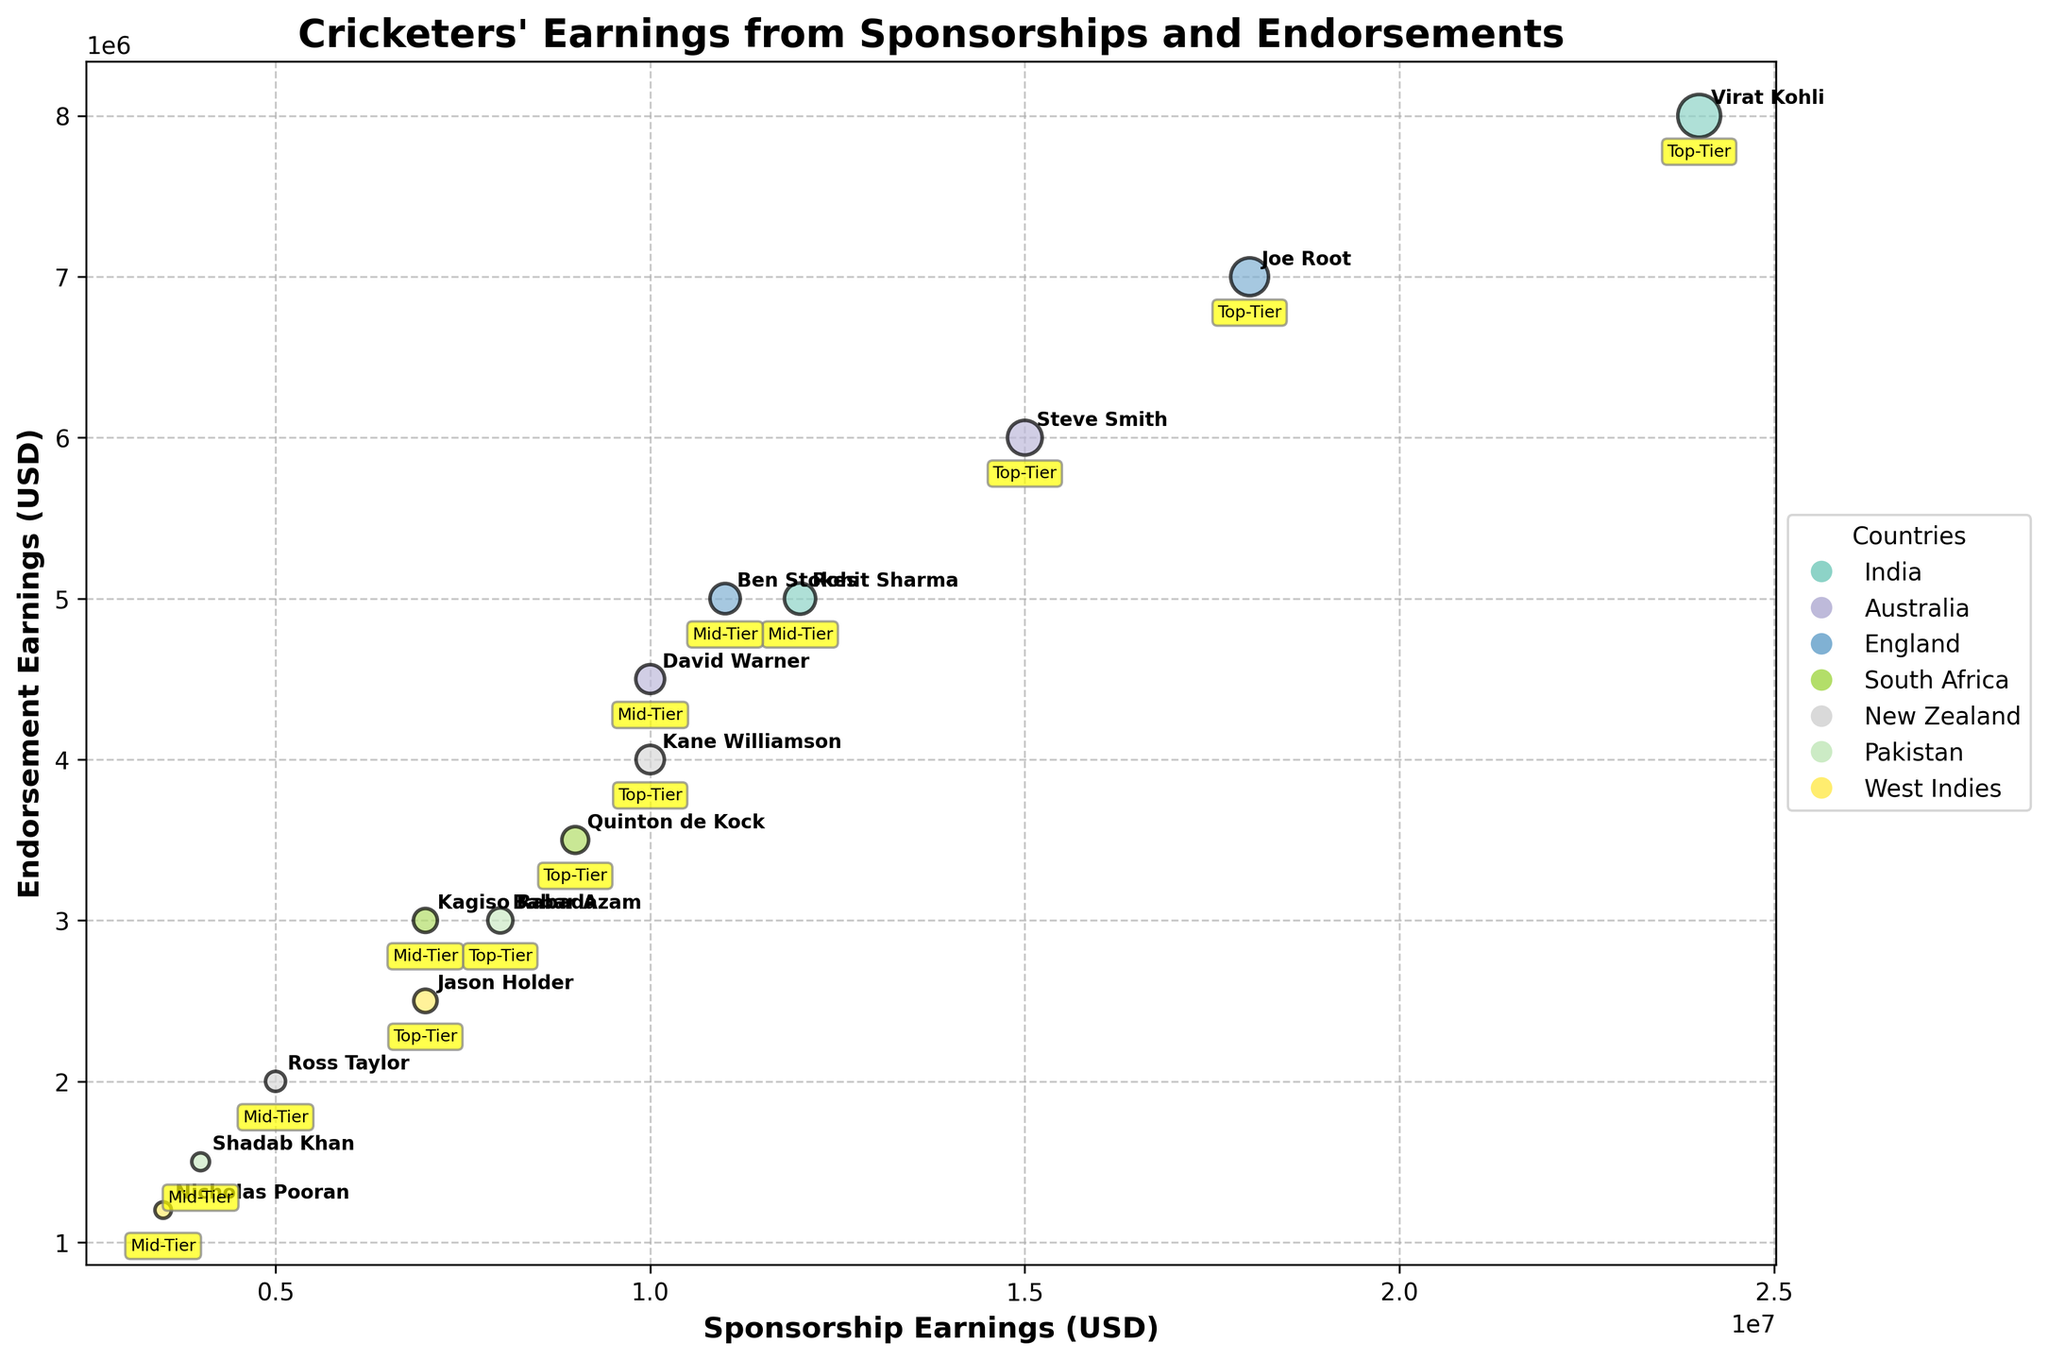Which country has the cricketer with the highest sponsorship earnings? By referring to the x-axis and noting the data points, we see that the highest sponsorship earnings are $24,000,000, associated with Virat Kohli from India.
Answer: India What is the range of endorsement earnings among top-tier cricketers? The endorsement earnings for top-tier cricketers range from the minimum $2,500,000 (Jason Holder) to the maximum $8,000,000 (Virat Kohli). So, the range is $8,000,000 - $2,500,000 = $5,500,000.
Answer: $5,500,000 Which player has the highest combined sponsorship and endorsement earnings? By evaluating the total earnings (sponsorship + endorsement) for each player, Virat Kohli has the highest combined earnings with $24,000,000 (sponsorship) + $8,000,000 (endorsement) = $32,000,000.
Answer: Virat Kohli What is the average sponsorship earning of mid-tier cricketers? Calculate the average by summing the sponsorship earnings for mid-tier cricketers and dividing by the number of mid-tier cricketers: (12,000,000 + 10,000,000 + 11,000,000 + 7,000,000 + 5,000,000 + 4,000,000 + 3,500,000) / 7 = $7,071,429.
Answer: $7,071,429 How does the endorsement earnings of Steve Smith compare to those of Joe Root? By locating Steve Smith and Joe Root on the y-axis: Steve Smith has $6,000,000 in endorsement earnings, while Joe Root has $7,000,000. Thus, Joe Root has higher endorsement earnings by $1,000,000.
Answer: Joe Root's are higher by $1,000,000 Which country has the most even distribution between sponsorship and endorsement earnings among its cricketers? By comparing the proximity of sponsorship and endorsement earnings for each country's players, we see that South Africa's players, Quinton de Kock and Kagiso Rabada, have relatively close values.
Answer: South Africa For players from New Zealand, who has higher sponsorship earnings, and by how much? Compare the sponsorship earnings of Kane Williamson ($10,000,000) and Ross Taylor ($5,000,000). Kane Williamson has higher sponsorship earnings by $10,000,000 - $5,000,000 = $5,000,000.
Answer: Kane Williamson, by $5,000,000 What is the sum of endorsement earnings for all players from Pakistan? Sum the endorsement earnings for Babar Azam ($3,000,000) and Shadab Khan ($1,500,000): $3,000,000 + $1,500,000 = $4,500,000.
Answer: $4,500,000 Which player representing the West Indies has higher combined earnings, and what is the difference? Calculate the combined earnings for Jason Holder ($7,000,000 + $2,500,000) and Nicholas Pooran ($3,500,000 + $1,200,000). Holder has larger combined earnings (difference of ($9,500,000 - $4,700,000) = $4,800,000).
Answer: Jason Holder, by $4,800,000 